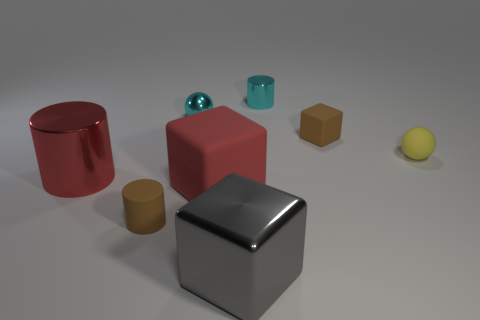Are there more brown matte cubes on the right side of the yellow thing than tiny spheres?
Your response must be concise. No. What number of other objects are the same size as the yellow sphere?
Offer a very short reply. 4. Do the small matte cylinder and the big metal cube have the same color?
Ensure brevity in your answer.  No. What color is the big cube that is behind the thing that is in front of the small brown object to the left of the big rubber object?
Ensure brevity in your answer.  Red. There is a large red thing that is right of the big object that is left of the tiny matte cylinder; how many blocks are to the right of it?
Give a very brief answer. 2. Is there anything else that has the same color as the matte cylinder?
Provide a succinct answer. Yes. There is a shiny cylinder that is to the right of the shiny ball; does it have the same size as the tiny metallic sphere?
Make the answer very short. Yes. How many small matte balls are in front of the metal cylinder in front of the tiny shiny ball?
Keep it short and to the point. 0. There is a tiny brown matte thing that is behind the big red object that is to the left of the shiny sphere; are there any tiny brown matte objects that are in front of it?
Make the answer very short. Yes. There is a large gray object that is the same shape as the large red rubber object; what is its material?
Offer a very short reply. Metal. 